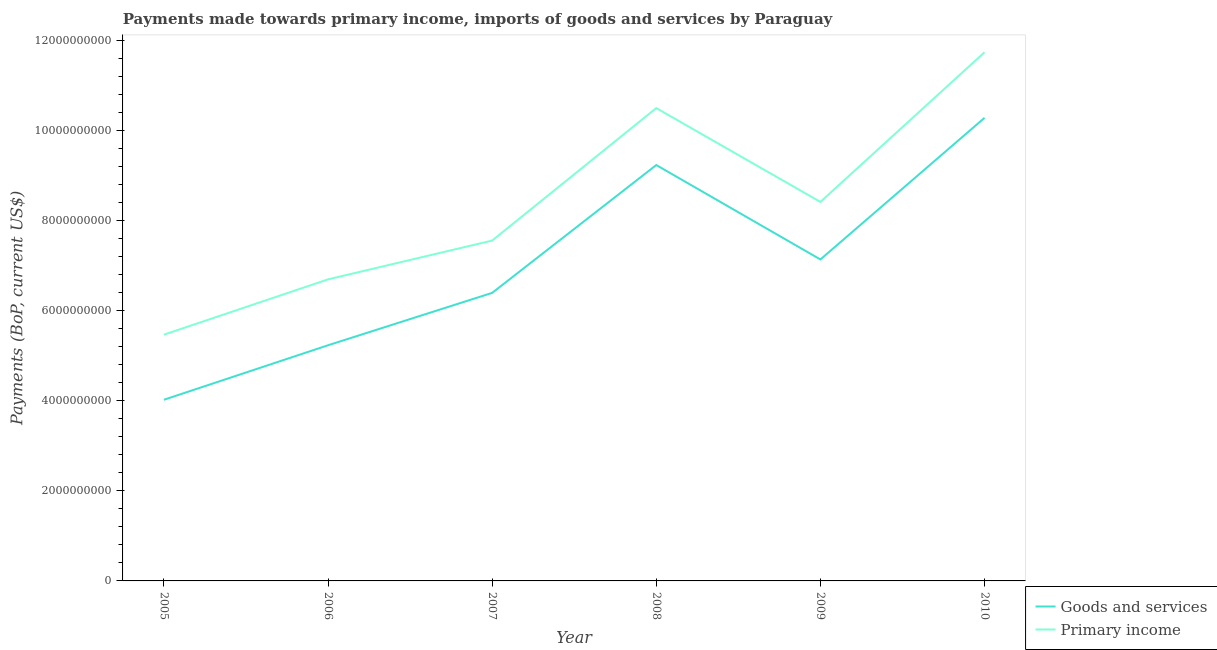How many different coloured lines are there?
Provide a succinct answer. 2. What is the payments made towards goods and services in 2007?
Your answer should be compact. 6.40e+09. Across all years, what is the maximum payments made towards goods and services?
Make the answer very short. 1.03e+1. Across all years, what is the minimum payments made towards primary income?
Give a very brief answer. 5.47e+09. In which year was the payments made towards primary income minimum?
Offer a terse response. 2005. What is the total payments made towards goods and services in the graph?
Offer a terse response. 4.23e+1. What is the difference between the payments made towards goods and services in 2008 and that in 2009?
Make the answer very short. 2.10e+09. What is the difference between the payments made towards goods and services in 2005 and the payments made towards primary income in 2010?
Your answer should be very brief. -7.72e+09. What is the average payments made towards primary income per year?
Your response must be concise. 8.40e+09. In the year 2007, what is the difference between the payments made towards goods and services and payments made towards primary income?
Give a very brief answer. -1.16e+09. What is the ratio of the payments made towards goods and services in 2005 to that in 2010?
Provide a succinct answer. 0.39. Is the payments made towards goods and services in 2007 less than that in 2010?
Ensure brevity in your answer.  Yes. Is the difference between the payments made towards primary income in 2007 and 2009 greater than the difference between the payments made towards goods and services in 2007 and 2009?
Make the answer very short. No. What is the difference between the highest and the second highest payments made towards goods and services?
Ensure brevity in your answer.  1.05e+09. What is the difference between the highest and the lowest payments made towards primary income?
Offer a very short reply. 6.28e+09. Is the sum of the payments made towards goods and services in 2005 and 2009 greater than the maximum payments made towards primary income across all years?
Your answer should be very brief. No. Is the payments made towards goods and services strictly less than the payments made towards primary income over the years?
Provide a short and direct response. Yes. How many lines are there?
Ensure brevity in your answer.  2. What is the difference between two consecutive major ticks on the Y-axis?
Make the answer very short. 2.00e+09. Are the values on the major ticks of Y-axis written in scientific E-notation?
Your answer should be compact. No. Does the graph contain grids?
Provide a succinct answer. No. Where does the legend appear in the graph?
Make the answer very short. Bottom right. How many legend labels are there?
Provide a succinct answer. 2. How are the legend labels stacked?
Keep it short and to the point. Vertical. What is the title of the graph?
Ensure brevity in your answer.  Payments made towards primary income, imports of goods and services by Paraguay. Does "Age 65(female)" appear as one of the legend labels in the graph?
Keep it short and to the point. No. What is the label or title of the Y-axis?
Provide a short and direct response. Payments (BoP, current US$). What is the Payments (BoP, current US$) of Goods and services in 2005?
Give a very brief answer. 4.03e+09. What is the Payments (BoP, current US$) of Primary income in 2005?
Ensure brevity in your answer.  5.47e+09. What is the Payments (BoP, current US$) in Goods and services in 2006?
Give a very brief answer. 5.24e+09. What is the Payments (BoP, current US$) in Primary income in 2006?
Provide a succinct answer. 6.70e+09. What is the Payments (BoP, current US$) in Goods and services in 2007?
Give a very brief answer. 6.40e+09. What is the Payments (BoP, current US$) in Primary income in 2007?
Ensure brevity in your answer.  7.56e+09. What is the Payments (BoP, current US$) in Goods and services in 2008?
Offer a very short reply. 9.24e+09. What is the Payments (BoP, current US$) in Primary income in 2008?
Ensure brevity in your answer.  1.05e+1. What is the Payments (BoP, current US$) in Goods and services in 2009?
Provide a succinct answer. 7.14e+09. What is the Payments (BoP, current US$) in Primary income in 2009?
Offer a very short reply. 8.42e+09. What is the Payments (BoP, current US$) in Goods and services in 2010?
Your response must be concise. 1.03e+1. What is the Payments (BoP, current US$) in Primary income in 2010?
Offer a very short reply. 1.17e+1. Across all years, what is the maximum Payments (BoP, current US$) of Goods and services?
Your response must be concise. 1.03e+1. Across all years, what is the maximum Payments (BoP, current US$) in Primary income?
Provide a succinct answer. 1.17e+1. Across all years, what is the minimum Payments (BoP, current US$) in Goods and services?
Your response must be concise. 4.03e+09. Across all years, what is the minimum Payments (BoP, current US$) of Primary income?
Make the answer very short. 5.47e+09. What is the total Payments (BoP, current US$) in Goods and services in the graph?
Provide a succinct answer. 4.23e+1. What is the total Payments (BoP, current US$) of Primary income in the graph?
Give a very brief answer. 5.04e+1. What is the difference between the Payments (BoP, current US$) of Goods and services in 2005 and that in 2006?
Provide a short and direct response. -1.21e+09. What is the difference between the Payments (BoP, current US$) in Primary income in 2005 and that in 2006?
Your answer should be very brief. -1.23e+09. What is the difference between the Payments (BoP, current US$) in Goods and services in 2005 and that in 2007?
Keep it short and to the point. -2.38e+09. What is the difference between the Payments (BoP, current US$) of Primary income in 2005 and that in 2007?
Keep it short and to the point. -2.09e+09. What is the difference between the Payments (BoP, current US$) in Goods and services in 2005 and that in 2008?
Make the answer very short. -5.22e+09. What is the difference between the Payments (BoP, current US$) in Primary income in 2005 and that in 2008?
Ensure brevity in your answer.  -5.04e+09. What is the difference between the Payments (BoP, current US$) of Goods and services in 2005 and that in 2009?
Provide a short and direct response. -3.12e+09. What is the difference between the Payments (BoP, current US$) of Primary income in 2005 and that in 2009?
Your answer should be very brief. -2.95e+09. What is the difference between the Payments (BoP, current US$) in Goods and services in 2005 and that in 2010?
Give a very brief answer. -6.27e+09. What is the difference between the Payments (BoP, current US$) in Primary income in 2005 and that in 2010?
Make the answer very short. -6.28e+09. What is the difference between the Payments (BoP, current US$) of Goods and services in 2006 and that in 2007?
Your response must be concise. -1.16e+09. What is the difference between the Payments (BoP, current US$) in Primary income in 2006 and that in 2007?
Your answer should be compact. -8.62e+08. What is the difference between the Payments (BoP, current US$) in Goods and services in 2006 and that in 2008?
Your answer should be compact. -4.01e+09. What is the difference between the Payments (BoP, current US$) in Primary income in 2006 and that in 2008?
Offer a very short reply. -3.81e+09. What is the difference between the Payments (BoP, current US$) of Goods and services in 2006 and that in 2009?
Provide a short and direct response. -1.91e+09. What is the difference between the Payments (BoP, current US$) of Primary income in 2006 and that in 2009?
Provide a succinct answer. -1.72e+09. What is the difference between the Payments (BoP, current US$) of Goods and services in 2006 and that in 2010?
Provide a short and direct response. -5.05e+09. What is the difference between the Payments (BoP, current US$) of Primary income in 2006 and that in 2010?
Your response must be concise. -5.05e+09. What is the difference between the Payments (BoP, current US$) of Goods and services in 2007 and that in 2008?
Your response must be concise. -2.84e+09. What is the difference between the Payments (BoP, current US$) in Primary income in 2007 and that in 2008?
Provide a succinct answer. -2.94e+09. What is the difference between the Payments (BoP, current US$) of Goods and services in 2007 and that in 2009?
Your response must be concise. -7.43e+08. What is the difference between the Payments (BoP, current US$) in Primary income in 2007 and that in 2009?
Offer a very short reply. -8.59e+08. What is the difference between the Payments (BoP, current US$) of Goods and services in 2007 and that in 2010?
Provide a short and direct response. -3.89e+09. What is the difference between the Payments (BoP, current US$) of Primary income in 2007 and that in 2010?
Give a very brief answer. -4.19e+09. What is the difference between the Payments (BoP, current US$) of Goods and services in 2008 and that in 2009?
Offer a very short reply. 2.10e+09. What is the difference between the Payments (BoP, current US$) of Primary income in 2008 and that in 2009?
Provide a short and direct response. 2.09e+09. What is the difference between the Payments (BoP, current US$) in Goods and services in 2008 and that in 2010?
Offer a terse response. -1.05e+09. What is the difference between the Payments (BoP, current US$) in Primary income in 2008 and that in 2010?
Your answer should be very brief. -1.24e+09. What is the difference between the Payments (BoP, current US$) in Goods and services in 2009 and that in 2010?
Your answer should be compact. -3.15e+09. What is the difference between the Payments (BoP, current US$) of Primary income in 2009 and that in 2010?
Ensure brevity in your answer.  -3.33e+09. What is the difference between the Payments (BoP, current US$) of Goods and services in 2005 and the Payments (BoP, current US$) of Primary income in 2006?
Your answer should be compact. -2.68e+09. What is the difference between the Payments (BoP, current US$) in Goods and services in 2005 and the Payments (BoP, current US$) in Primary income in 2007?
Keep it short and to the point. -3.54e+09. What is the difference between the Payments (BoP, current US$) in Goods and services in 2005 and the Payments (BoP, current US$) in Primary income in 2008?
Ensure brevity in your answer.  -6.48e+09. What is the difference between the Payments (BoP, current US$) of Goods and services in 2005 and the Payments (BoP, current US$) of Primary income in 2009?
Give a very brief answer. -4.40e+09. What is the difference between the Payments (BoP, current US$) of Goods and services in 2005 and the Payments (BoP, current US$) of Primary income in 2010?
Provide a succinct answer. -7.72e+09. What is the difference between the Payments (BoP, current US$) in Goods and services in 2006 and the Payments (BoP, current US$) in Primary income in 2007?
Your response must be concise. -2.33e+09. What is the difference between the Payments (BoP, current US$) of Goods and services in 2006 and the Payments (BoP, current US$) of Primary income in 2008?
Offer a terse response. -5.27e+09. What is the difference between the Payments (BoP, current US$) of Goods and services in 2006 and the Payments (BoP, current US$) of Primary income in 2009?
Your answer should be compact. -3.19e+09. What is the difference between the Payments (BoP, current US$) of Goods and services in 2006 and the Payments (BoP, current US$) of Primary income in 2010?
Your answer should be very brief. -6.51e+09. What is the difference between the Payments (BoP, current US$) of Goods and services in 2007 and the Payments (BoP, current US$) of Primary income in 2008?
Offer a very short reply. -4.11e+09. What is the difference between the Payments (BoP, current US$) in Goods and services in 2007 and the Payments (BoP, current US$) in Primary income in 2009?
Your answer should be very brief. -2.02e+09. What is the difference between the Payments (BoP, current US$) of Goods and services in 2007 and the Payments (BoP, current US$) of Primary income in 2010?
Offer a very short reply. -5.35e+09. What is the difference between the Payments (BoP, current US$) in Goods and services in 2008 and the Payments (BoP, current US$) in Primary income in 2009?
Offer a very short reply. 8.20e+08. What is the difference between the Payments (BoP, current US$) in Goods and services in 2008 and the Payments (BoP, current US$) in Primary income in 2010?
Make the answer very short. -2.51e+09. What is the difference between the Payments (BoP, current US$) of Goods and services in 2009 and the Payments (BoP, current US$) of Primary income in 2010?
Provide a short and direct response. -4.61e+09. What is the average Payments (BoP, current US$) in Goods and services per year?
Offer a terse response. 7.06e+09. What is the average Payments (BoP, current US$) in Primary income per year?
Give a very brief answer. 8.40e+09. In the year 2005, what is the difference between the Payments (BoP, current US$) in Goods and services and Payments (BoP, current US$) in Primary income?
Offer a terse response. -1.45e+09. In the year 2006, what is the difference between the Payments (BoP, current US$) in Goods and services and Payments (BoP, current US$) in Primary income?
Ensure brevity in your answer.  -1.46e+09. In the year 2007, what is the difference between the Payments (BoP, current US$) of Goods and services and Payments (BoP, current US$) of Primary income?
Offer a terse response. -1.16e+09. In the year 2008, what is the difference between the Payments (BoP, current US$) of Goods and services and Payments (BoP, current US$) of Primary income?
Your answer should be compact. -1.27e+09. In the year 2009, what is the difference between the Payments (BoP, current US$) in Goods and services and Payments (BoP, current US$) in Primary income?
Your response must be concise. -1.28e+09. In the year 2010, what is the difference between the Payments (BoP, current US$) of Goods and services and Payments (BoP, current US$) of Primary income?
Your answer should be compact. -1.46e+09. What is the ratio of the Payments (BoP, current US$) of Goods and services in 2005 to that in 2006?
Offer a very short reply. 0.77. What is the ratio of the Payments (BoP, current US$) in Primary income in 2005 to that in 2006?
Your response must be concise. 0.82. What is the ratio of the Payments (BoP, current US$) of Goods and services in 2005 to that in 2007?
Offer a terse response. 0.63. What is the ratio of the Payments (BoP, current US$) of Primary income in 2005 to that in 2007?
Give a very brief answer. 0.72. What is the ratio of the Payments (BoP, current US$) of Goods and services in 2005 to that in 2008?
Your response must be concise. 0.44. What is the ratio of the Payments (BoP, current US$) of Primary income in 2005 to that in 2008?
Give a very brief answer. 0.52. What is the ratio of the Payments (BoP, current US$) in Goods and services in 2005 to that in 2009?
Provide a short and direct response. 0.56. What is the ratio of the Payments (BoP, current US$) of Primary income in 2005 to that in 2009?
Offer a terse response. 0.65. What is the ratio of the Payments (BoP, current US$) of Goods and services in 2005 to that in 2010?
Your answer should be very brief. 0.39. What is the ratio of the Payments (BoP, current US$) of Primary income in 2005 to that in 2010?
Your answer should be compact. 0.47. What is the ratio of the Payments (BoP, current US$) in Goods and services in 2006 to that in 2007?
Provide a succinct answer. 0.82. What is the ratio of the Payments (BoP, current US$) in Primary income in 2006 to that in 2007?
Offer a very short reply. 0.89. What is the ratio of the Payments (BoP, current US$) of Goods and services in 2006 to that in 2008?
Make the answer very short. 0.57. What is the ratio of the Payments (BoP, current US$) of Primary income in 2006 to that in 2008?
Your answer should be compact. 0.64. What is the ratio of the Payments (BoP, current US$) in Goods and services in 2006 to that in 2009?
Your answer should be very brief. 0.73. What is the ratio of the Payments (BoP, current US$) in Primary income in 2006 to that in 2009?
Provide a succinct answer. 0.8. What is the ratio of the Payments (BoP, current US$) in Goods and services in 2006 to that in 2010?
Provide a succinct answer. 0.51. What is the ratio of the Payments (BoP, current US$) of Primary income in 2006 to that in 2010?
Provide a short and direct response. 0.57. What is the ratio of the Payments (BoP, current US$) in Goods and services in 2007 to that in 2008?
Offer a very short reply. 0.69. What is the ratio of the Payments (BoP, current US$) of Primary income in 2007 to that in 2008?
Your response must be concise. 0.72. What is the ratio of the Payments (BoP, current US$) of Goods and services in 2007 to that in 2009?
Offer a very short reply. 0.9. What is the ratio of the Payments (BoP, current US$) in Primary income in 2007 to that in 2009?
Your answer should be very brief. 0.9. What is the ratio of the Payments (BoP, current US$) of Goods and services in 2007 to that in 2010?
Your response must be concise. 0.62. What is the ratio of the Payments (BoP, current US$) of Primary income in 2007 to that in 2010?
Your answer should be compact. 0.64. What is the ratio of the Payments (BoP, current US$) of Goods and services in 2008 to that in 2009?
Ensure brevity in your answer.  1.29. What is the ratio of the Payments (BoP, current US$) of Primary income in 2008 to that in 2009?
Provide a succinct answer. 1.25. What is the ratio of the Payments (BoP, current US$) in Goods and services in 2008 to that in 2010?
Offer a terse response. 0.9. What is the ratio of the Payments (BoP, current US$) of Primary income in 2008 to that in 2010?
Give a very brief answer. 0.89. What is the ratio of the Payments (BoP, current US$) in Goods and services in 2009 to that in 2010?
Keep it short and to the point. 0.69. What is the ratio of the Payments (BoP, current US$) of Primary income in 2009 to that in 2010?
Offer a terse response. 0.72. What is the difference between the highest and the second highest Payments (BoP, current US$) of Goods and services?
Your answer should be very brief. 1.05e+09. What is the difference between the highest and the second highest Payments (BoP, current US$) of Primary income?
Provide a short and direct response. 1.24e+09. What is the difference between the highest and the lowest Payments (BoP, current US$) in Goods and services?
Provide a short and direct response. 6.27e+09. What is the difference between the highest and the lowest Payments (BoP, current US$) in Primary income?
Offer a very short reply. 6.28e+09. 